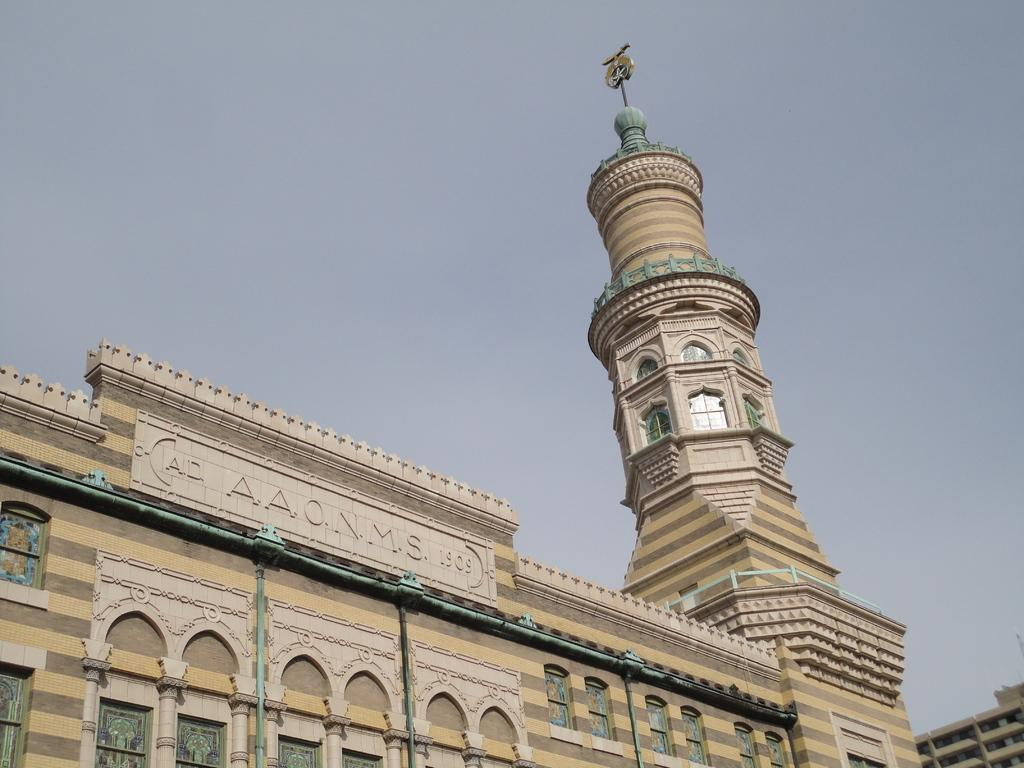What type of structure is present in the image? There is a building in the image. What else can be seen in the image besides the building? There is a board in the image. What can be seen in the background of the image? The sky is visible in the background of the image. How many giants are visible in the image? There are no giants present in the image. What type of pan is being used to cook on the board in the image? There is no pan visible in the image, as it only features a building, a board, and the sky. 